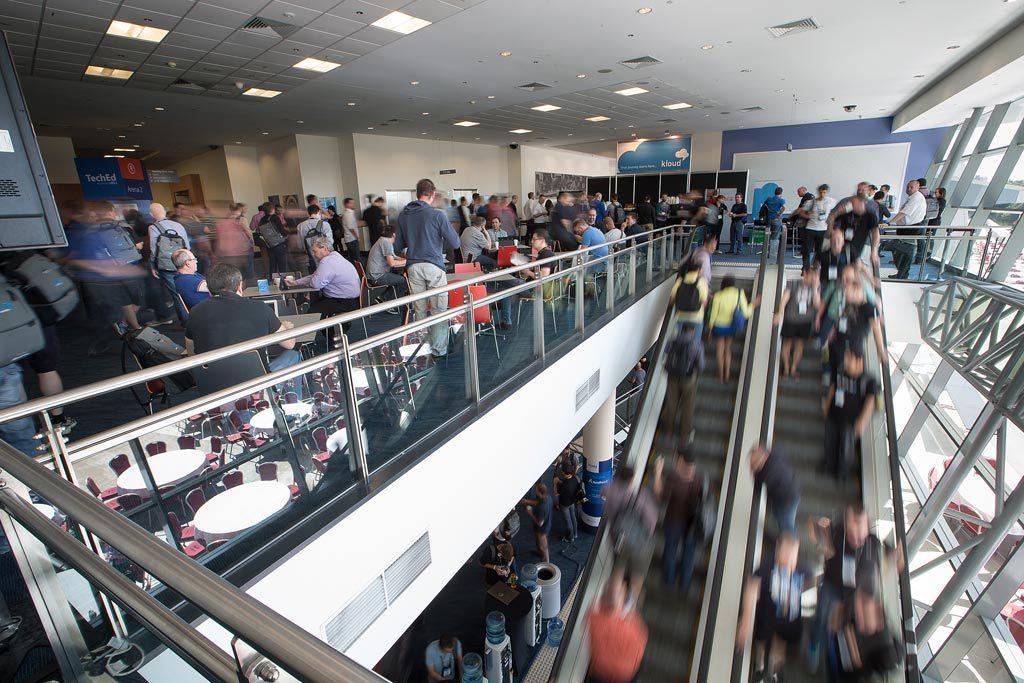Could you give a brief overview of what you see in this image? In this image I can see the interior of the building in which I can see few stairs, few persons on the stairs, the glass railing, few chairs, few tables, few persons sitting, few persons standing, few boards, the windows, the walls, the ceiling and few lights to the ceiling. 